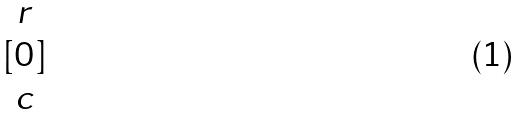Convert formula to latex. <formula><loc_0><loc_0><loc_500><loc_500>[ \begin{matrix} r \\ 0 \\ c \end{matrix} ]</formula> 